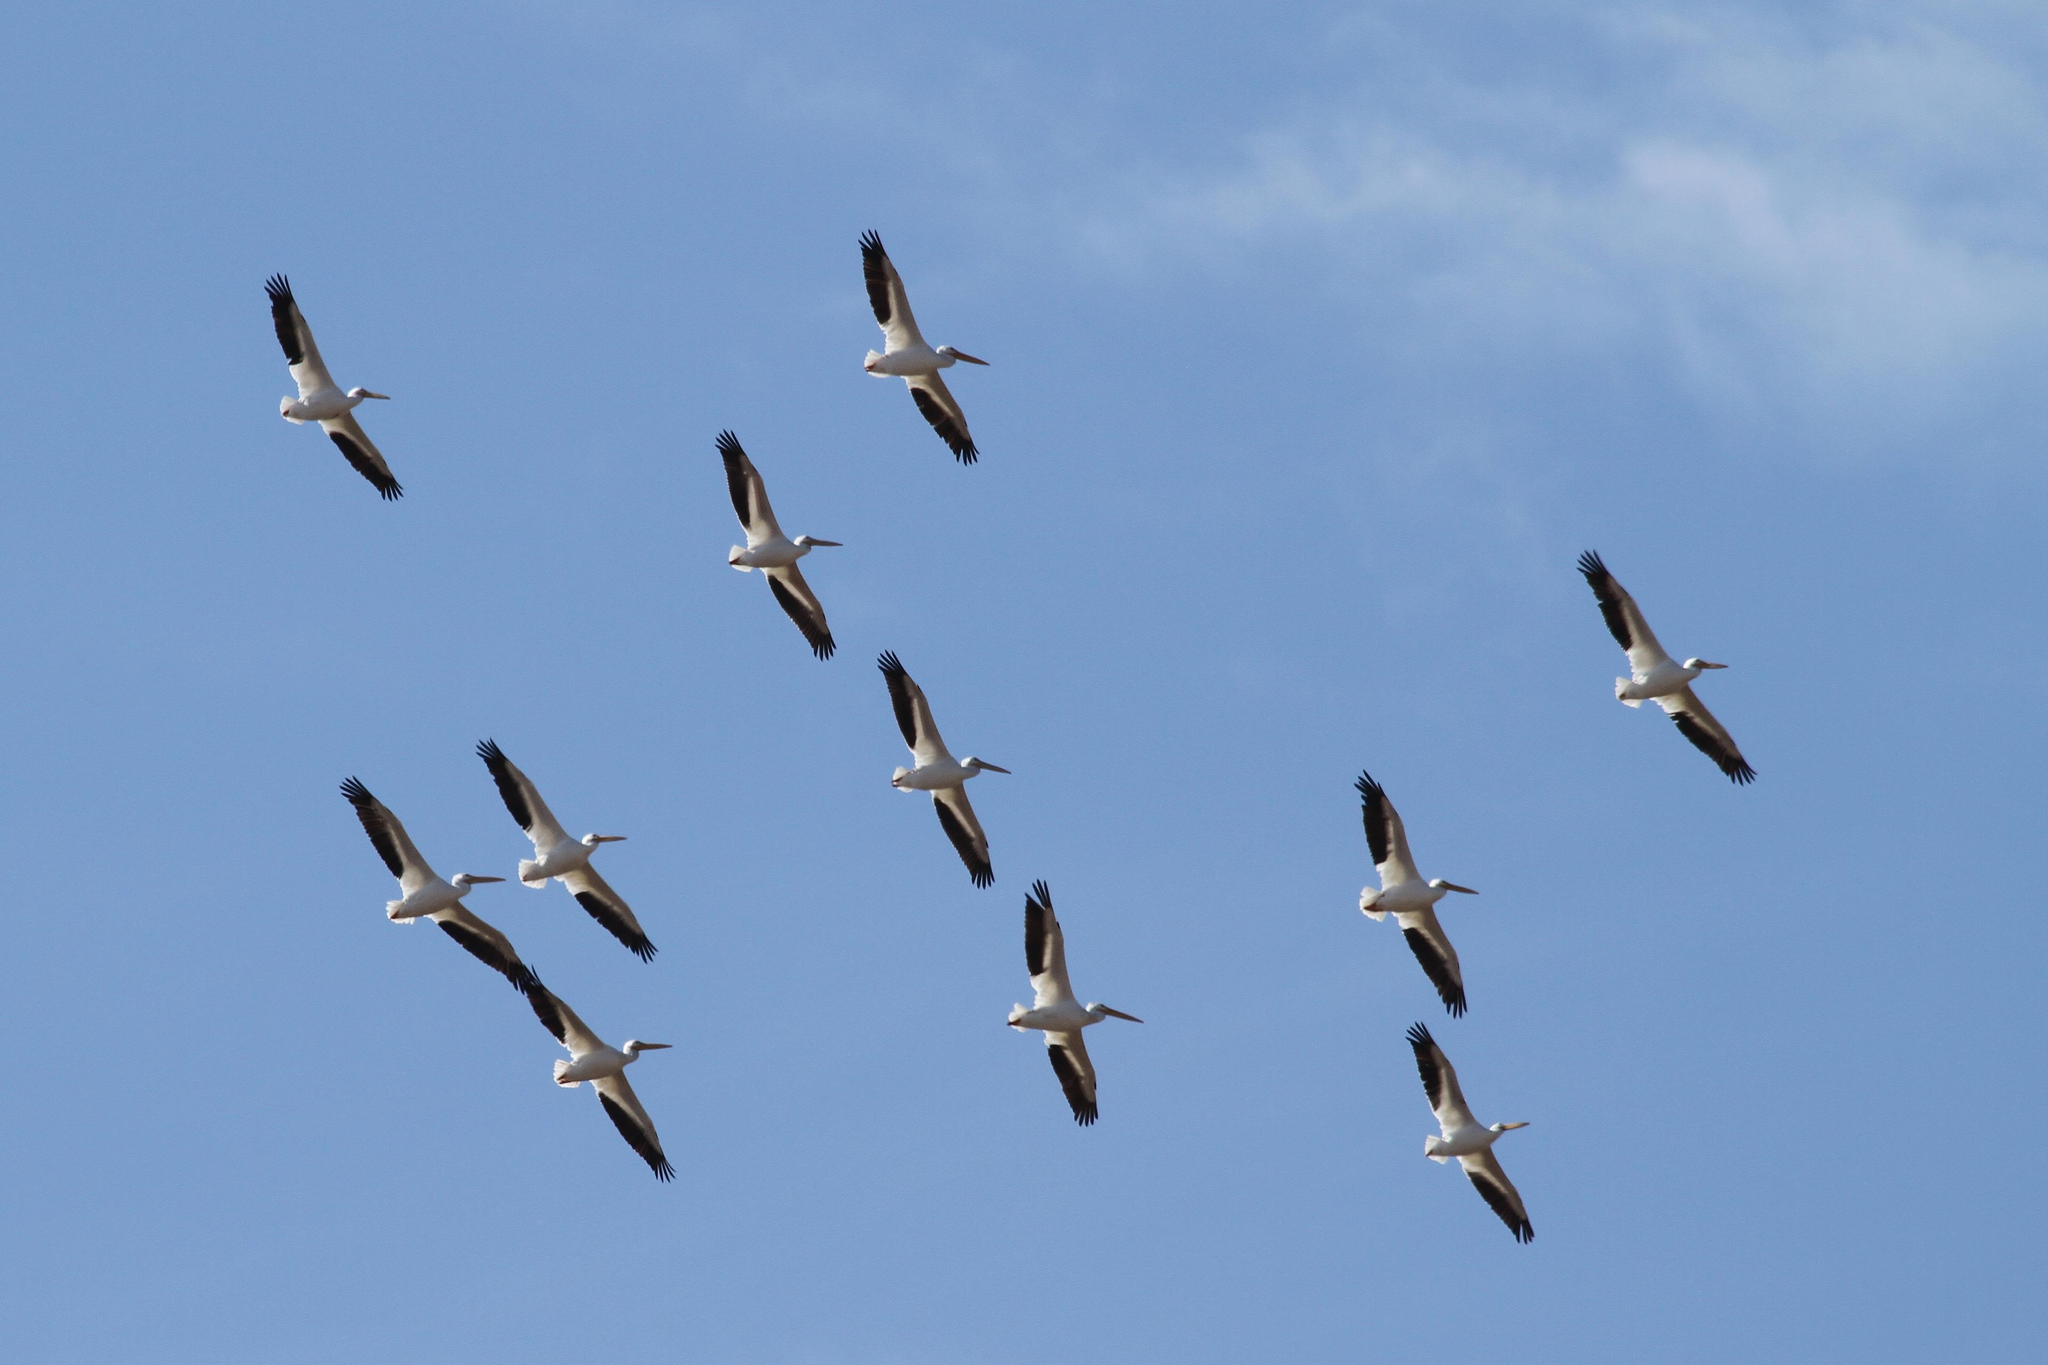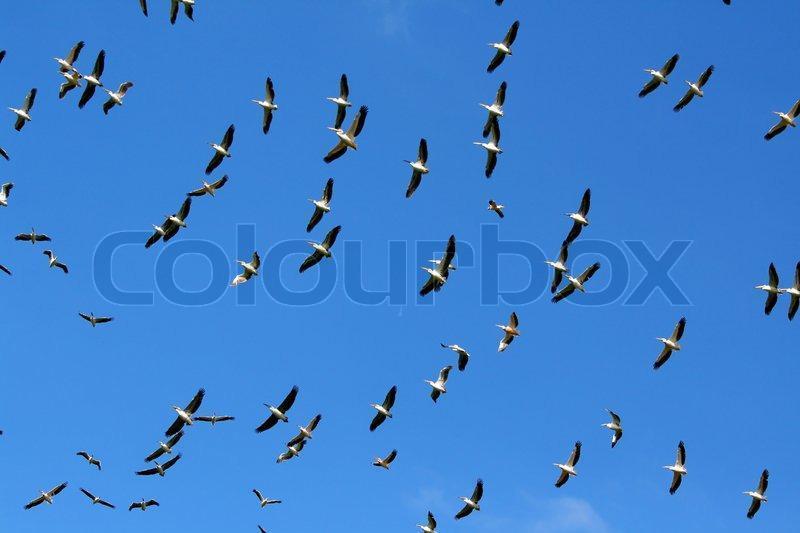The first image is the image on the left, the second image is the image on the right. Analyze the images presented: Is the assertion "One image contains less than 5 flying birds." valid? Answer yes or no. No. The first image is the image on the left, the second image is the image on the right. Considering the images on both sides, is "Four or fewer birds are flying through the air in one image." valid? Answer yes or no. No. 